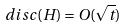Convert formula to latex. <formula><loc_0><loc_0><loc_500><loc_500>d i s c ( H ) = O ( \sqrt { t } )</formula> 